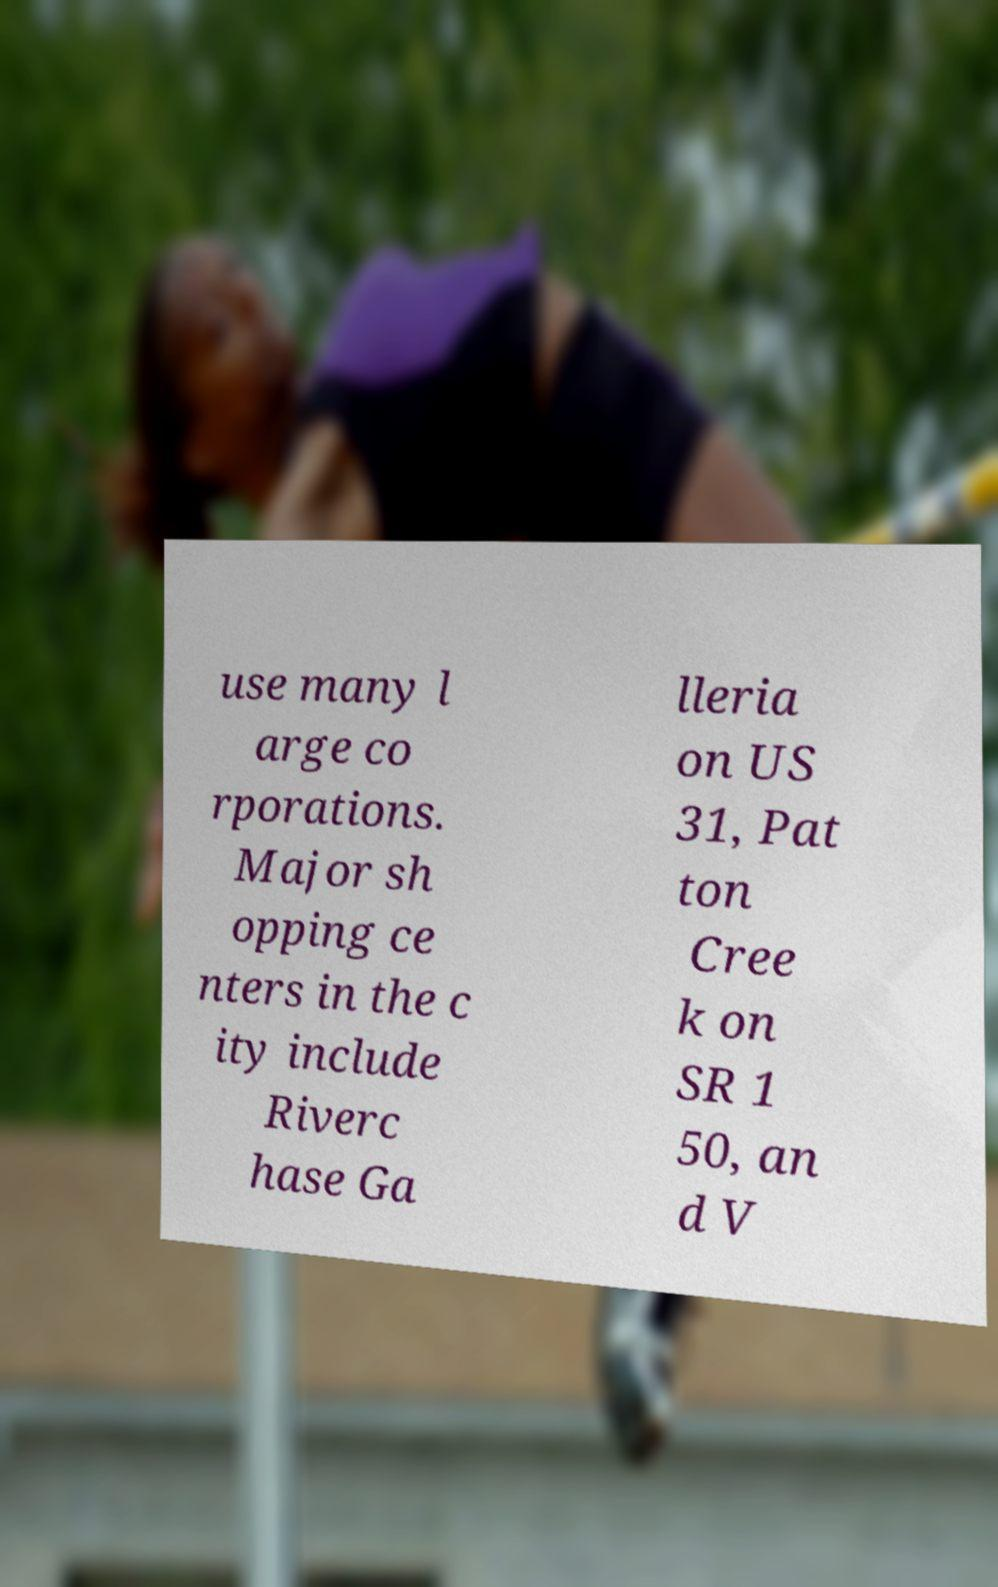Could you extract and type out the text from this image? use many l arge co rporations. Major sh opping ce nters in the c ity include Riverc hase Ga lleria on US 31, Pat ton Cree k on SR 1 50, an d V 